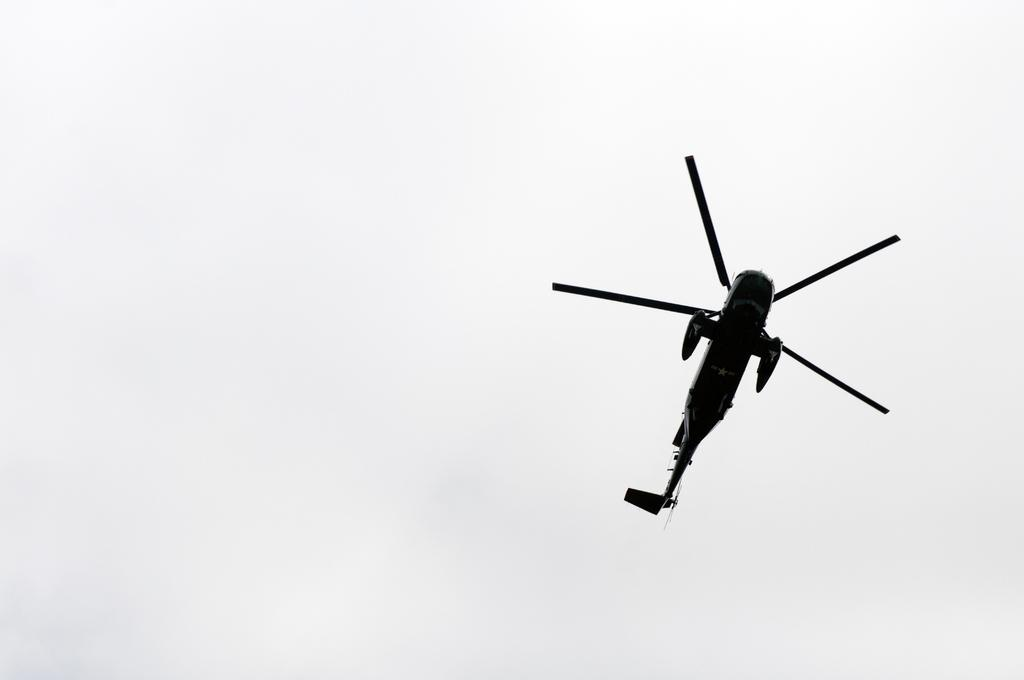What is the main subject of the image? The main subject of the image is an aircraft. What can be seen in the background of the image? There is a sky visible in the image. What type of eggs does the mom cook for the self in the image? There is no reference to eggs, a mom, or cooking in the image; it features an aircraft and a sky. 